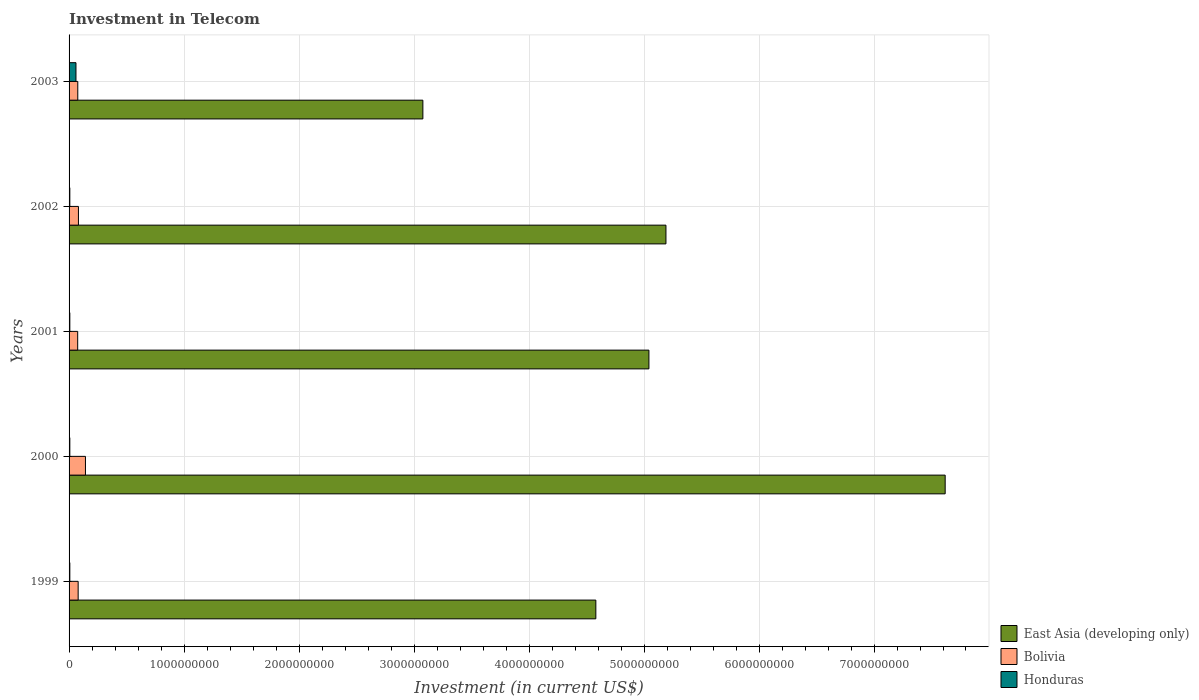How many different coloured bars are there?
Your answer should be compact. 3. How many groups of bars are there?
Your response must be concise. 5. Are the number of bars per tick equal to the number of legend labels?
Keep it short and to the point. Yes. How many bars are there on the 3rd tick from the top?
Your answer should be compact. 3. How many bars are there on the 4th tick from the bottom?
Your response must be concise. 3. In how many cases, is the number of bars for a given year not equal to the number of legend labels?
Provide a succinct answer. 0. What is the amount invested in telecom in Honduras in 2003?
Offer a terse response. 6.00e+07. Across all years, what is the maximum amount invested in telecom in Bolivia?
Ensure brevity in your answer.  1.42e+08. Across all years, what is the minimum amount invested in telecom in Honduras?
Provide a short and direct response. 6.60e+06. In which year was the amount invested in telecom in Honduras maximum?
Your response must be concise. 2003. What is the total amount invested in telecom in East Asia (developing only) in the graph?
Offer a terse response. 2.55e+1. What is the difference between the amount invested in telecom in East Asia (developing only) in 2002 and that in 2003?
Provide a succinct answer. 2.11e+09. What is the difference between the amount invested in telecom in Honduras in 2000 and the amount invested in telecom in East Asia (developing only) in 2003?
Your answer should be compact. -3.07e+09. What is the average amount invested in telecom in Bolivia per year?
Offer a terse response. 9.07e+07. In the year 2001, what is the difference between the amount invested in telecom in Honduras and amount invested in telecom in East Asia (developing only)?
Your answer should be very brief. -5.04e+09. What is the difference between the highest and the second highest amount invested in telecom in Honduras?
Your response must be concise. 5.34e+07. What is the difference between the highest and the lowest amount invested in telecom in Bolivia?
Ensure brevity in your answer.  6.74e+07. What does the 3rd bar from the bottom in 1999 represents?
Offer a very short reply. Honduras. How many bars are there?
Give a very brief answer. 15. Are all the bars in the graph horizontal?
Offer a terse response. Yes. How many years are there in the graph?
Make the answer very short. 5. Where does the legend appear in the graph?
Your answer should be very brief. Bottom right. How are the legend labels stacked?
Ensure brevity in your answer.  Vertical. What is the title of the graph?
Provide a short and direct response. Investment in Telecom. What is the label or title of the X-axis?
Keep it short and to the point. Investment (in current US$). What is the label or title of the Y-axis?
Provide a short and direct response. Years. What is the Investment (in current US$) in East Asia (developing only) in 1999?
Your response must be concise. 4.58e+09. What is the Investment (in current US$) in Bolivia in 1999?
Your response must be concise. 7.90e+07. What is the Investment (in current US$) in Honduras in 1999?
Ensure brevity in your answer.  6.60e+06. What is the Investment (in current US$) of East Asia (developing only) in 2000?
Provide a succinct answer. 7.62e+09. What is the Investment (in current US$) in Bolivia in 2000?
Provide a short and direct response. 1.42e+08. What is the Investment (in current US$) in Honduras in 2000?
Provide a short and direct response. 6.60e+06. What is the Investment (in current US$) of East Asia (developing only) in 2001?
Provide a short and direct response. 5.04e+09. What is the Investment (in current US$) of Bolivia in 2001?
Your response must be concise. 7.50e+07. What is the Investment (in current US$) of Honduras in 2001?
Provide a short and direct response. 6.60e+06. What is the Investment (in current US$) in East Asia (developing only) in 2002?
Your response must be concise. 5.19e+09. What is the Investment (in current US$) of Bolivia in 2002?
Your answer should be very brief. 8.15e+07. What is the Investment (in current US$) of Honduras in 2002?
Your answer should be very brief. 6.60e+06. What is the Investment (in current US$) of East Asia (developing only) in 2003?
Offer a very short reply. 3.08e+09. What is the Investment (in current US$) of Bolivia in 2003?
Give a very brief answer. 7.58e+07. What is the Investment (in current US$) in Honduras in 2003?
Provide a short and direct response. 6.00e+07. Across all years, what is the maximum Investment (in current US$) in East Asia (developing only)?
Provide a succinct answer. 7.62e+09. Across all years, what is the maximum Investment (in current US$) of Bolivia?
Offer a very short reply. 1.42e+08. Across all years, what is the maximum Investment (in current US$) in Honduras?
Keep it short and to the point. 6.00e+07. Across all years, what is the minimum Investment (in current US$) of East Asia (developing only)?
Provide a short and direct response. 3.08e+09. Across all years, what is the minimum Investment (in current US$) of Bolivia?
Offer a very short reply. 7.50e+07. Across all years, what is the minimum Investment (in current US$) in Honduras?
Give a very brief answer. 6.60e+06. What is the total Investment (in current US$) of East Asia (developing only) in the graph?
Give a very brief answer. 2.55e+1. What is the total Investment (in current US$) in Bolivia in the graph?
Your answer should be compact. 4.54e+08. What is the total Investment (in current US$) of Honduras in the graph?
Your answer should be compact. 8.64e+07. What is the difference between the Investment (in current US$) in East Asia (developing only) in 1999 and that in 2000?
Make the answer very short. -3.04e+09. What is the difference between the Investment (in current US$) in Bolivia in 1999 and that in 2000?
Provide a succinct answer. -6.34e+07. What is the difference between the Investment (in current US$) of Honduras in 1999 and that in 2000?
Offer a terse response. 0. What is the difference between the Investment (in current US$) in East Asia (developing only) in 1999 and that in 2001?
Keep it short and to the point. -4.62e+08. What is the difference between the Investment (in current US$) in East Asia (developing only) in 1999 and that in 2002?
Provide a succinct answer. -6.10e+08. What is the difference between the Investment (in current US$) in Bolivia in 1999 and that in 2002?
Make the answer very short. -2.50e+06. What is the difference between the Investment (in current US$) of East Asia (developing only) in 1999 and that in 2003?
Your answer should be very brief. 1.50e+09. What is the difference between the Investment (in current US$) in Bolivia in 1999 and that in 2003?
Your answer should be compact. 3.20e+06. What is the difference between the Investment (in current US$) of Honduras in 1999 and that in 2003?
Give a very brief answer. -5.34e+07. What is the difference between the Investment (in current US$) of East Asia (developing only) in 2000 and that in 2001?
Provide a succinct answer. 2.58e+09. What is the difference between the Investment (in current US$) in Bolivia in 2000 and that in 2001?
Your answer should be compact. 6.74e+07. What is the difference between the Investment (in current US$) in East Asia (developing only) in 2000 and that in 2002?
Offer a very short reply. 2.43e+09. What is the difference between the Investment (in current US$) in Bolivia in 2000 and that in 2002?
Your answer should be compact. 6.09e+07. What is the difference between the Investment (in current US$) in East Asia (developing only) in 2000 and that in 2003?
Your answer should be very brief. 4.54e+09. What is the difference between the Investment (in current US$) of Bolivia in 2000 and that in 2003?
Ensure brevity in your answer.  6.66e+07. What is the difference between the Investment (in current US$) in Honduras in 2000 and that in 2003?
Give a very brief answer. -5.34e+07. What is the difference between the Investment (in current US$) in East Asia (developing only) in 2001 and that in 2002?
Provide a succinct answer. -1.48e+08. What is the difference between the Investment (in current US$) in Bolivia in 2001 and that in 2002?
Ensure brevity in your answer.  -6.50e+06. What is the difference between the Investment (in current US$) in East Asia (developing only) in 2001 and that in 2003?
Your response must be concise. 1.97e+09. What is the difference between the Investment (in current US$) of Bolivia in 2001 and that in 2003?
Offer a terse response. -8.00e+05. What is the difference between the Investment (in current US$) in Honduras in 2001 and that in 2003?
Your response must be concise. -5.34e+07. What is the difference between the Investment (in current US$) of East Asia (developing only) in 2002 and that in 2003?
Offer a very short reply. 2.11e+09. What is the difference between the Investment (in current US$) in Bolivia in 2002 and that in 2003?
Your response must be concise. 5.70e+06. What is the difference between the Investment (in current US$) of Honduras in 2002 and that in 2003?
Ensure brevity in your answer.  -5.34e+07. What is the difference between the Investment (in current US$) of East Asia (developing only) in 1999 and the Investment (in current US$) of Bolivia in 2000?
Offer a very short reply. 4.44e+09. What is the difference between the Investment (in current US$) of East Asia (developing only) in 1999 and the Investment (in current US$) of Honduras in 2000?
Your response must be concise. 4.57e+09. What is the difference between the Investment (in current US$) in Bolivia in 1999 and the Investment (in current US$) in Honduras in 2000?
Your answer should be very brief. 7.24e+07. What is the difference between the Investment (in current US$) of East Asia (developing only) in 1999 and the Investment (in current US$) of Bolivia in 2001?
Provide a succinct answer. 4.51e+09. What is the difference between the Investment (in current US$) of East Asia (developing only) in 1999 and the Investment (in current US$) of Honduras in 2001?
Provide a short and direct response. 4.57e+09. What is the difference between the Investment (in current US$) in Bolivia in 1999 and the Investment (in current US$) in Honduras in 2001?
Give a very brief answer. 7.24e+07. What is the difference between the Investment (in current US$) of East Asia (developing only) in 1999 and the Investment (in current US$) of Bolivia in 2002?
Your response must be concise. 4.50e+09. What is the difference between the Investment (in current US$) of East Asia (developing only) in 1999 and the Investment (in current US$) of Honduras in 2002?
Keep it short and to the point. 4.57e+09. What is the difference between the Investment (in current US$) in Bolivia in 1999 and the Investment (in current US$) in Honduras in 2002?
Ensure brevity in your answer.  7.24e+07. What is the difference between the Investment (in current US$) of East Asia (developing only) in 1999 and the Investment (in current US$) of Bolivia in 2003?
Keep it short and to the point. 4.51e+09. What is the difference between the Investment (in current US$) in East Asia (developing only) in 1999 and the Investment (in current US$) in Honduras in 2003?
Ensure brevity in your answer.  4.52e+09. What is the difference between the Investment (in current US$) in Bolivia in 1999 and the Investment (in current US$) in Honduras in 2003?
Provide a short and direct response. 1.90e+07. What is the difference between the Investment (in current US$) in East Asia (developing only) in 2000 and the Investment (in current US$) in Bolivia in 2001?
Provide a short and direct response. 7.54e+09. What is the difference between the Investment (in current US$) in East Asia (developing only) in 2000 and the Investment (in current US$) in Honduras in 2001?
Keep it short and to the point. 7.61e+09. What is the difference between the Investment (in current US$) of Bolivia in 2000 and the Investment (in current US$) of Honduras in 2001?
Make the answer very short. 1.36e+08. What is the difference between the Investment (in current US$) of East Asia (developing only) in 2000 and the Investment (in current US$) of Bolivia in 2002?
Provide a short and direct response. 7.54e+09. What is the difference between the Investment (in current US$) in East Asia (developing only) in 2000 and the Investment (in current US$) in Honduras in 2002?
Keep it short and to the point. 7.61e+09. What is the difference between the Investment (in current US$) of Bolivia in 2000 and the Investment (in current US$) of Honduras in 2002?
Your answer should be very brief. 1.36e+08. What is the difference between the Investment (in current US$) of East Asia (developing only) in 2000 and the Investment (in current US$) of Bolivia in 2003?
Your answer should be compact. 7.54e+09. What is the difference between the Investment (in current US$) in East Asia (developing only) in 2000 and the Investment (in current US$) in Honduras in 2003?
Give a very brief answer. 7.56e+09. What is the difference between the Investment (in current US$) of Bolivia in 2000 and the Investment (in current US$) of Honduras in 2003?
Ensure brevity in your answer.  8.24e+07. What is the difference between the Investment (in current US$) of East Asia (developing only) in 2001 and the Investment (in current US$) of Bolivia in 2002?
Your response must be concise. 4.96e+09. What is the difference between the Investment (in current US$) in East Asia (developing only) in 2001 and the Investment (in current US$) in Honduras in 2002?
Provide a succinct answer. 5.04e+09. What is the difference between the Investment (in current US$) of Bolivia in 2001 and the Investment (in current US$) of Honduras in 2002?
Keep it short and to the point. 6.84e+07. What is the difference between the Investment (in current US$) in East Asia (developing only) in 2001 and the Investment (in current US$) in Bolivia in 2003?
Your answer should be very brief. 4.97e+09. What is the difference between the Investment (in current US$) of East Asia (developing only) in 2001 and the Investment (in current US$) of Honduras in 2003?
Offer a terse response. 4.98e+09. What is the difference between the Investment (in current US$) of Bolivia in 2001 and the Investment (in current US$) of Honduras in 2003?
Provide a succinct answer. 1.50e+07. What is the difference between the Investment (in current US$) of East Asia (developing only) in 2002 and the Investment (in current US$) of Bolivia in 2003?
Make the answer very short. 5.11e+09. What is the difference between the Investment (in current US$) in East Asia (developing only) in 2002 and the Investment (in current US$) in Honduras in 2003?
Offer a terse response. 5.13e+09. What is the difference between the Investment (in current US$) in Bolivia in 2002 and the Investment (in current US$) in Honduras in 2003?
Provide a succinct answer. 2.15e+07. What is the average Investment (in current US$) of East Asia (developing only) per year?
Offer a terse response. 5.10e+09. What is the average Investment (in current US$) in Bolivia per year?
Your answer should be very brief. 9.07e+07. What is the average Investment (in current US$) in Honduras per year?
Your answer should be very brief. 1.73e+07. In the year 1999, what is the difference between the Investment (in current US$) in East Asia (developing only) and Investment (in current US$) in Bolivia?
Offer a terse response. 4.50e+09. In the year 1999, what is the difference between the Investment (in current US$) of East Asia (developing only) and Investment (in current US$) of Honduras?
Offer a very short reply. 4.57e+09. In the year 1999, what is the difference between the Investment (in current US$) in Bolivia and Investment (in current US$) in Honduras?
Your answer should be compact. 7.24e+07. In the year 2000, what is the difference between the Investment (in current US$) of East Asia (developing only) and Investment (in current US$) of Bolivia?
Your answer should be very brief. 7.48e+09. In the year 2000, what is the difference between the Investment (in current US$) in East Asia (developing only) and Investment (in current US$) in Honduras?
Offer a very short reply. 7.61e+09. In the year 2000, what is the difference between the Investment (in current US$) in Bolivia and Investment (in current US$) in Honduras?
Make the answer very short. 1.36e+08. In the year 2001, what is the difference between the Investment (in current US$) in East Asia (developing only) and Investment (in current US$) in Bolivia?
Keep it short and to the point. 4.97e+09. In the year 2001, what is the difference between the Investment (in current US$) in East Asia (developing only) and Investment (in current US$) in Honduras?
Offer a very short reply. 5.04e+09. In the year 2001, what is the difference between the Investment (in current US$) of Bolivia and Investment (in current US$) of Honduras?
Offer a very short reply. 6.84e+07. In the year 2002, what is the difference between the Investment (in current US$) in East Asia (developing only) and Investment (in current US$) in Bolivia?
Ensure brevity in your answer.  5.11e+09. In the year 2002, what is the difference between the Investment (in current US$) of East Asia (developing only) and Investment (in current US$) of Honduras?
Ensure brevity in your answer.  5.18e+09. In the year 2002, what is the difference between the Investment (in current US$) of Bolivia and Investment (in current US$) of Honduras?
Your answer should be very brief. 7.49e+07. In the year 2003, what is the difference between the Investment (in current US$) in East Asia (developing only) and Investment (in current US$) in Bolivia?
Your answer should be very brief. 3.00e+09. In the year 2003, what is the difference between the Investment (in current US$) in East Asia (developing only) and Investment (in current US$) in Honduras?
Offer a terse response. 3.02e+09. In the year 2003, what is the difference between the Investment (in current US$) in Bolivia and Investment (in current US$) in Honduras?
Offer a very short reply. 1.58e+07. What is the ratio of the Investment (in current US$) in East Asia (developing only) in 1999 to that in 2000?
Offer a terse response. 0.6. What is the ratio of the Investment (in current US$) of Bolivia in 1999 to that in 2000?
Your response must be concise. 0.55. What is the ratio of the Investment (in current US$) of East Asia (developing only) in 1999 to that in 2001?
Your answer should be compact. 0.91. What is the ratio of the Investment (in current US$) of Bolivia in 1999 to that in 2001?
Provide a short and direct response. 1.05. What is the ratio of the Investment (in current US$) of Honduras in 1999 to that in 2001?
Make the answer very short. 1. What is the ratio of the Investment (in current US$) in East Asia (developing only) in 1999 to that in 2002?
Provide a succinct answer. 0.88. What is the ratio of the Investment (in current US$) in Bolivia in 1999 to that in 2002?
Your answer should be compact. 0.97. What is the ratio of the Investment (in current US$) of Honduras in 1999 to that in 2002?
Give a very brief answer. 1. What is the ratio of the Investment (in current US$) of East Asia (developing only) in 1999 to that in 2003?
Provide a succinct answer. 1.49. What is the ratio of the Investment (in current US$) in Bolivia in 1999 to that in 2003?
Provide a short and direct response. 1.04. What is the ratio of the Investment (in current US$) of Honduras in 1999 to that in 2003?
Provide a short and direct response. 0.11. What is the ratio of the Investment (in current US$) of East Asia (developing only) in 2000 to that in 2001?
Make the answer very short. 1.51. What is the ratio of the Investment (in current US$) of Bolivia in 2000 to that in 2001?
Your answer should be very brief. 1.9. What is the ratio of the Investment (in current US$) in East Asia (developing only) in 2000 to that in 2002?
Make the answer very short. 1.47. What is the ratio of the Investment (in current US$) of Bolivia in 2000 to that in 2002?
Offer a very short reply. 1.75. What is the ratio of the Investment (in current US$) in Honduras in 2000 to that in 2002?
Make the answer very short. 1. What is the ratio of the Investment (in current US$) of East Asia (developing only) in 2000 to that in 2003?
Keep it short and to the point. 2.48. What is the ratio of the Investment (in current US$) of Bolivia in 2000 to that in 2003?
Offer a terse response. 1.88. What is the ratio of the Investment (in current US$) in Honduras in 2000 to that in 2003?
Your answer should be very brief. 0.11. What is the ratio of the Investment (in current US$) in East Asia (developing only) in 2001 to that in 2002?
Your answer should be compact. 0.97. What is the ratio of the Investment (in current US$) in Bolivia in 2001 to that in 2002?
Your response must be concise. 0.92. What is the ratio of the Investment (in current US$) of East Asia (developing only) in 2001 to that in 2003?
Provide a succinct answer. 1.64. What is the ratio of the Investment (in current US$) of Honduras in 2001 to that in 2003?
Your response must be concise. 0.11. What is the ratio of the Investment (in current US$) in East Asia (developing only) in 2002 to that in 2003?
Your response must be concise. 1.69. What is the ratio of the Investment (in current US$) in Bolivia in 2002 to that in 2003?
Provide a succinct answer. 1.08. What is the ratio of the Investment (in current US$) in Honduras in 2002 to that in 2003?
Your answer should be compact. 0.11. What is the difference between the highest and the second highest Investment (in current US$) in East Asia (developing only)?
Offer a terse response. 2.43e+09. What is the difference between the highest and the second highest Investment (in current US$) of Bolivia?
Give a very brief answer. 6.09e+07. What is the difference between the highest and the second highest Investment (in current US$) of Honduras?
Your response must be concise. 5.34e+07. What is the difference between the highest and the lowest Investment (in current US$) in East Asia (developing only)?
Your response must be concise. 4.54e+09. What is the difference between the highest and the lowest Investment (in current US$) of Bolivia?
Provide a short and direct response. 6.74e+07. What is the difference between the highest and the lowest Investment (in current US$) of Honduras?
Offer a very short reply. 5.34e+07. 